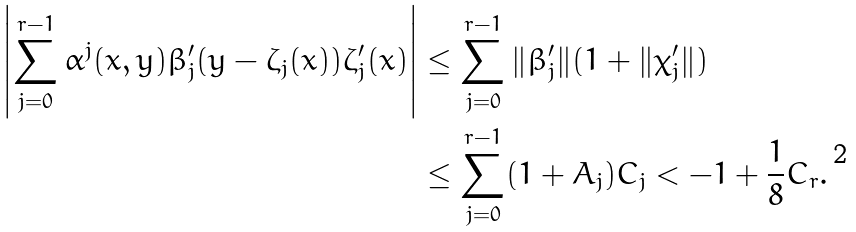<formula> <loc_0><loc_0><loc_500><loc_500>\left | \sum _ { j = 0 } ^ { r - 1 } \alpha ^ { j } ( x , y ) \beta ^ { \prime } _ { j } ( y - \zeta _ { j } ( x ) ) \zeta _ { j } ^ { \prime } ( x ) \right | & \leq \sum _ { j = 0 } ^ { r - 1 } \| \beta _ { j } ^ { \prime } \| ( 1 + \| \chi _ { j } ^ { \prime } \| ) \\ & \leq \sum _ { j = 0 } ^ { r - 1 } ( 1 + A _ { j } ) C _ { j } < - 1 + \frac { 1 } { 8 } C _ { r } .</formula> 